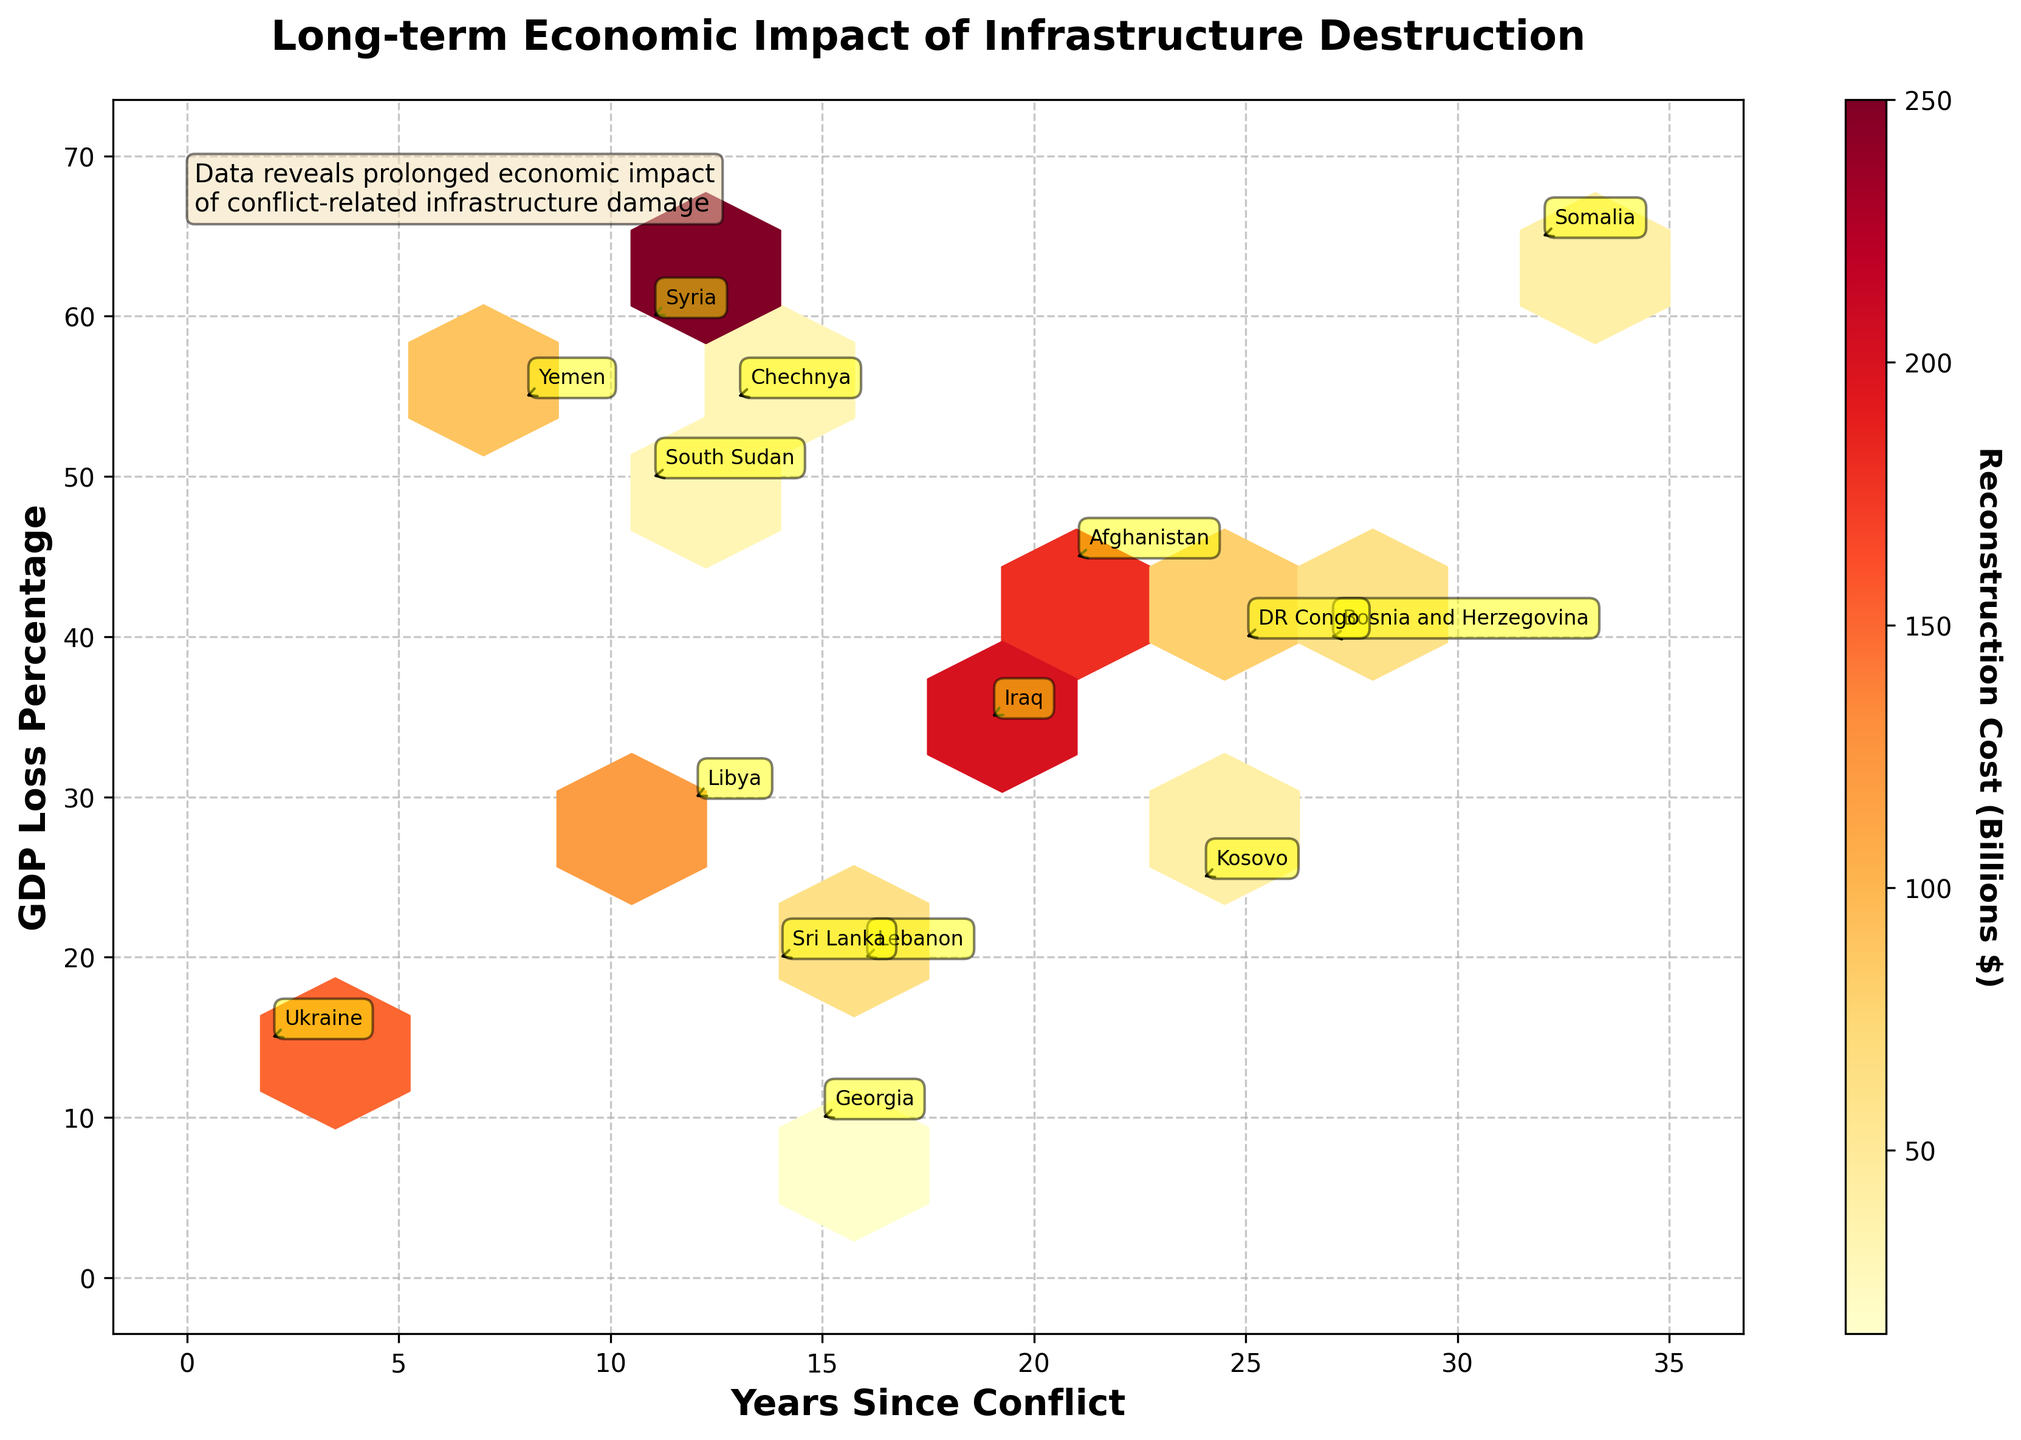What's the title of the figure? Look at the text displayed at the top of the plot, which is usually the title.
Answer: Long-term Economic Impact of Infrastructure Destruction What does the x-axis represent? Check the label on the horizontal axis to understand what it represents.
Answer: Years Since Conflict How many data points are approximately in the plot? By visually inspecting the plot, count the number of hexagonal bins containing data points.
Answer: Around 15 Which country has the highest GDP loss percentage? Identify the hexagon that is located at the highest vertical position (y-axis) and look for the corresponding country annotation.
Answer: Somalia What is the relationship between years since conflict and GDP loss percentage? Observe the overall trend and distribution of hexagons to determine if there is a visible pattern between years since conflict and GDP loss percentage.
Answer: No clear relationship Which country has the highest reconstruction cost? Refer to the color intensity of hexagons and find the one with the highest value in the color bar legend, then look for the corresponding country annotation.
Answer: Syria Which country has the lowest GDP loss percentage and what are its reconstruction costs? Identify the hexagon at the lowest vertical position (y-axis) and look for the corresponding country annotation, then check the color intensity of that hexagon.
Answer: Georgia, $15 billion What is the average reconstruction cost for countries with more than 20 years since conflict? Identify hexagons on the x-axis range greater than 20 and calculate the average of their color values. Average of DR Congo (80), Kosovo (40), Bosnia and Herzegovina (60), Somalia (40). So, (80+40+60+40)/4 = 55.
Answer: $55 billion Which country experienced the highest GDP loss percentage within the first 15 years since conflict? Focus on hexagons within the first 15 years on the x-axis and determine the one with the highest vertical position (y-axis) by referring to country annotations.
Answer: Syria What is the range of years since conflict covered in the plot? Check the minimum and maximum values on the x-axis to determine the range.
Answer: 2 to 32 years 